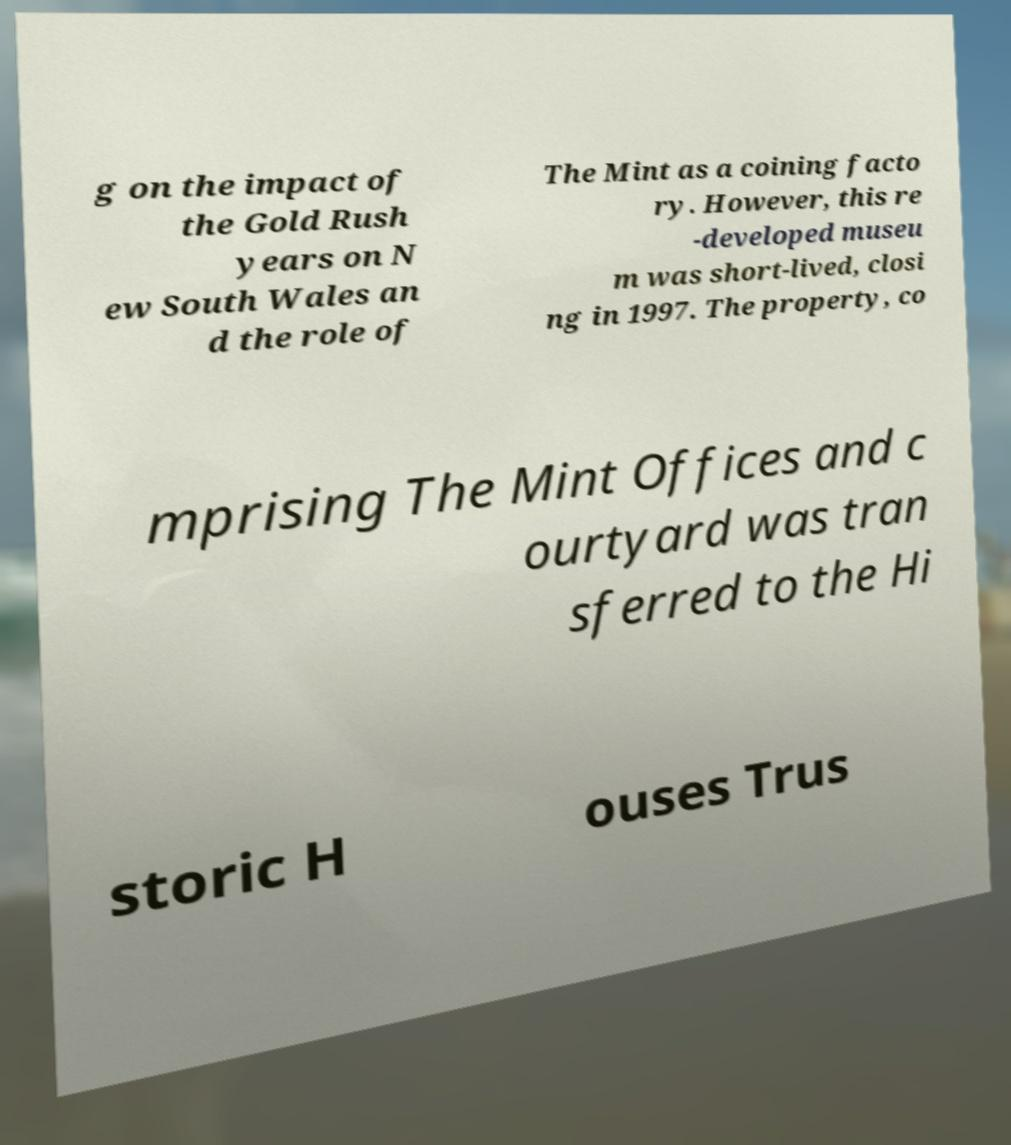Can you accurately transcribe the text from the provided image for me? g on the impact of the Gold Rush years on N ew South Wales an d the role of The Mint as a coining facto ry. However, this re -developed museu m was short-lived, closi ng in 1997. The property, co mprising The Mint Offices and c ourtyard was tran sferred to the Hi storic H ouses Trus 